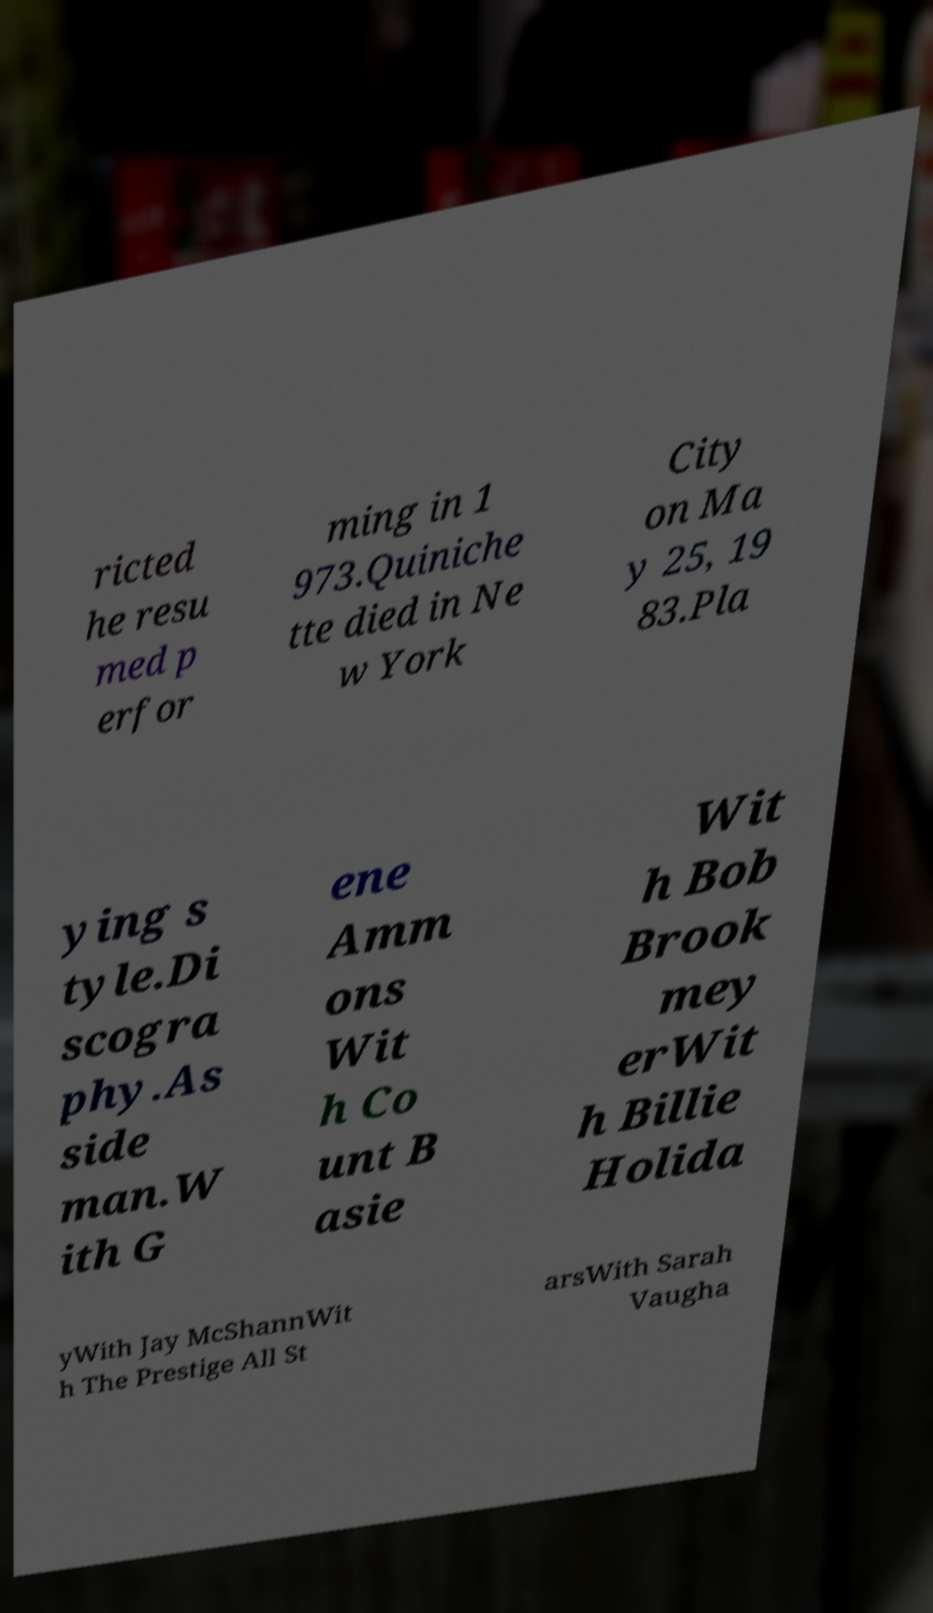I need the written content from this picture converted into text. Can you do that? ricted he resu med p erfor ming in 1 973.Quiniche tte died in Ne w York City on Ma y 25, 19 83.Pla ying s tyle.Di scogra phy.As side man.W ith G ene Amm ons Wit h Co unt B asie Wit h Bob Brook mey erWit h Billie Holida yWith Jay McShannWit h The Prestige All St arsWith Sarah Vaugha 